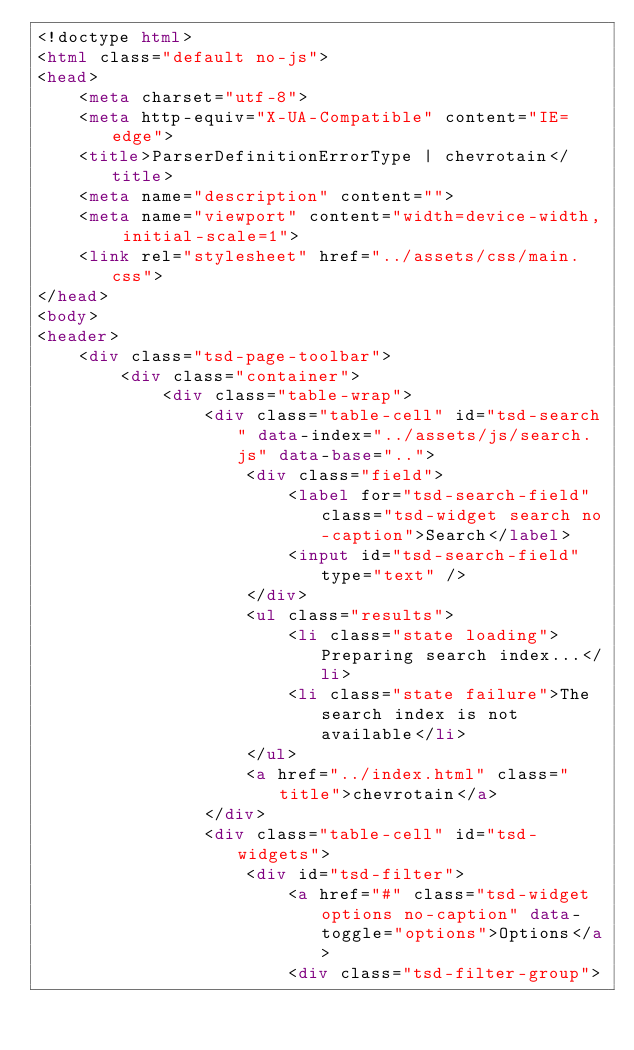<code> <loc_0><loc_0><loc_500><loc_500><_HTML_><!doctype html>
<html class="default no-js">
<head>
	<meta charset="utf-8">
	<meta http-equiv="X-UA-Compatible" content="IE=edge">
	<title>ParserDefinitionErrorType | chevrotain</title>
	<meta name="description" content="">
	<meta name="viewport" content="width=device-width, initial-scale=1">
	<link rel="stylesheet" href="../assets/css/main.css">
</head>
<body>
<header>
	<div class="tsd-page-toolbar">
		<div class="container">
			<div class="table-wrap">
				<div class="table-cell" id="tsd-search" data-index="../assets/js/search.js" data-base="..">
					<div class="field">
						<label for="tsd-search-field" class="tsd-widget search no-caption">Search</label>
						<input id="tsd-search-field" type="text" />
					</div>
					<ul class="results">
						<li class="state loading">Preparing search index...</li>
						<li class="state failure">The search index is not available</li>
					</ul>
					<a href="../index.html" class="title">chevrotain</a>
				</div>
				<div class="table-cell" id="tsd-widgets">
					<div id="tsd-filter">
						<a href="#" class="tsd-widget options no-caption" data-toggle="options">Options</a>
						<div class="tsd-filter-group"></code> 